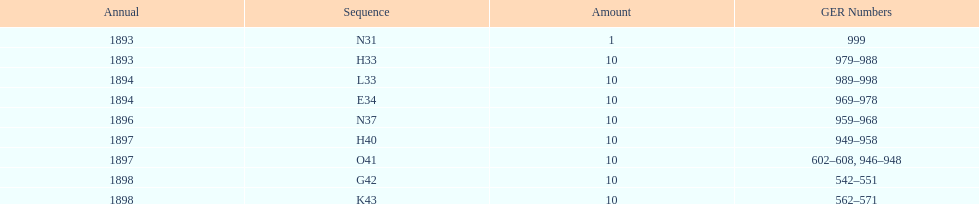What order is listed first at the top of the table? N31. 